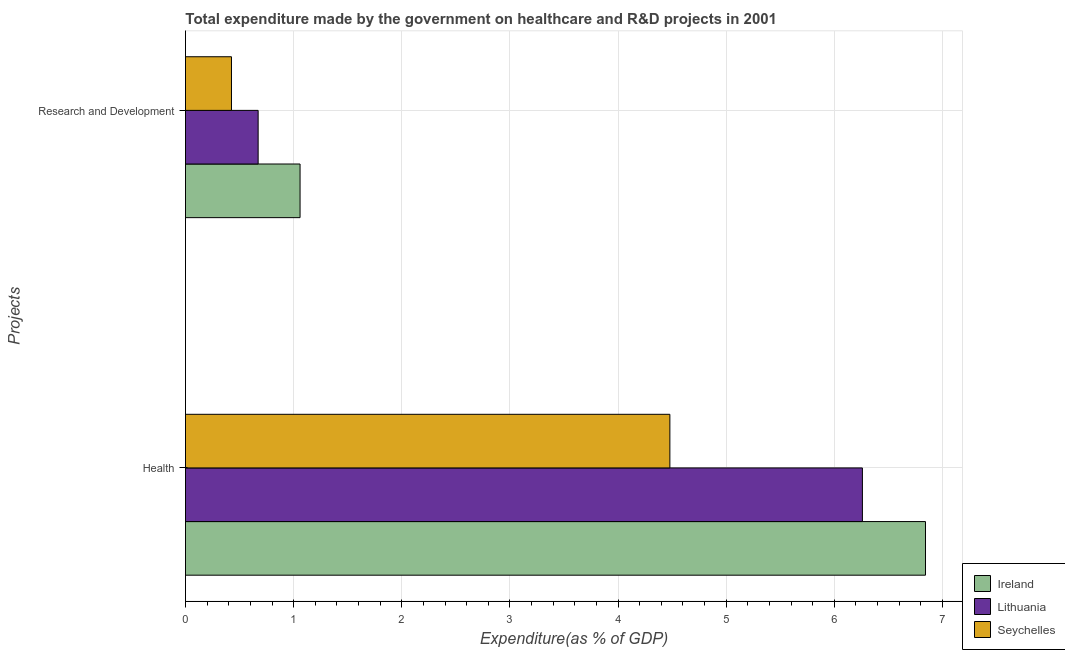How many groups of bars are there?
Your response must be concise. 2. What is the label of the 1st group of bars from the top?
Your answer should be compact. Research and Development. What is the expenditure in healthcare in Seychelles?
Offer a terse response. 4.48. Across all countries, what is the maximum expenditure in r&d?
Provide a short and direct response. 1.06. Across all countries, what is the minimum expenditure in healthcare?
Your answer should be compact. 4.48. In which country was the expenditure in r&d maximum?
Your answer should be compact. Ireland. In which country was the expenditure in r&d minimum?
Offer a terse response. Seychelles. What is the total expenditure in healthcare in the graph?
Give a very brief answer. 17.58. What is the difference between the expenditure in healthcare in Lithuania and that in Seychelles?
Make the answer very short. 1.78. What is the difference between the expenditure in r&d in Ireland and the expenditure in healthcare in Lithuania?
Keep it short and to the point. -5.2. What is the average expenditure in healthcare per country?
Your response must be concise. 5.86. What is the difference between the expenditure in healthcare and expenditure in r&d in Seychelles?
Your answer should be compact. 4.05. What is the ratio of the expenditure in healthcare in Seychelles to that in Ireland?
Your answer should be very brief. 0.65. Is the expenditure in r&d in Lithuania less than that in Seychelles?
Provide a short and direct response. No. What does the 2nd bar from the top in Research and Development represents?
Your answer should be very brief. Lithuania. What does the 1st bar from the bottom in Health represents?
Offer a very short reply. Ireland. How many bars are there?
Provide a succinct answer. 6. How many countries are there in the graph?
Your answer should be compact. 3. What is the difference between two consecutive major ticks on the X-axis?
Offer a very short reply. 1. Does the graph contain grids?
Provide a succinct answer. Yes. Where does the legend appear in the graph?
Give a very brief answer. Bottom right. How many legend labels are there?
Make the answer very short. 3. What is the title of the graph?
Give a very brief answer. Total expenditure made by the government on healthcare and R&D projects in 2001. Does "Timor-Leste" appear as one of the legend labels in the graph?
Keep it short and to the point. No. What is the label or title of the X-axis?
Offer a very short reply. Expenditure(as % of GDP). What is the label or title of the Y-axis?
Ensure brevity in your answer.  Projects. What is the Expenditure(as % of GDP) in Ireland in Health?
Ensure brevity in your answer.  6.84. What is the Expenditure(as % of GDP) of Lithuania in Health?
Give a very brief answer. 6.26. What is the Expenditure(as % of GDP) of Seychelles in Health?
Your response must be concise. 4.48. What is the Expenditure(as % of GDP) of Ireland in Research and Development?
Keep it short and to the point. 1.06. What is the Expenditure(as % of GDP) in Lithuania in Research and Development?
Ensure brevity in your answer.  0.67. What is the Expenditure(as % of GDP) of Seychelles in Research and Development?
Provide a short and direct response. 0.43. Across all Projects, what is the maximum Expenditure(as % of GDP) in Ireland?
Your answer should be very brief. 6.84. Across all Projects, what is the maximum Expenditure(as % of GDP) in Lithuania?
Keep it short and to the point. 6.26. Across all Projects, what is the maximum Expenditure(as % of GDP) of Seychelles?
Provide a succinct answer. 4.48. Across all Projects, what is the minimum Expenditure(as % of GDP) of Ireland?
Your answer should be very brief. 1.06. Across all Projects, what is the minimum Expenditure(as % of GDP) in Lithuania?
Provide a succinct answer. 0.67. Across all Projects, what is the minimum Expenditure(as % of GDP) in Seychelles?
Keep it short and to the point. 0.43. What is the total Expenditure(as % of GDP) in Ireland in the graph?
Your answer should be compact. 7.9. What is the total Expenditure(as % of GDP) of Lithuania in the graph?
Offer a very short reply. 6.93. What is the total Expenditure(as % of GDP) of Seychelles in the graph?
Offer a terse response. 4.9. What is the difference between the Expenditure(as % of GDP) in Ireland in Health and that in Research and Development?
Offer a terse response. 5.78. What is the difference between the Expenditure(as % of GDP) in Lithuania in Health and that in Research and Development?
Keep it short and to the point. 5.59. What is the difference between the Expenditure(as % of GDP) in Seychelles in Health and that in Research and Development?
Provide a succinct answer. 4.05. What is the difference between the Expenditure(as % of GDP) in Ireland in Health and the Expenditure(as % of GDP) in Lithuania in Research and Development?
Your answer should be compact. 6.17. What is the difference between the Expenditure(as % of GDP) in Ireland in Health and the Expenditure(as % of GDP) in Seychelles in Research and Development?
Offer a very short reply. 6.42. What is the difference between the Expenditure(as % of GDP) of Lithuania in Health and the Expenditure(as % of GDP) of Seychelles in Research and Development?
Keep it short and to the point. 5.83. What is the average Expenditure(as % of GDP) of Ireland per Projects?
Give a very brief answer. 3.95. What is the average Expenditure(as % of GDP) in Lithuania per Projects?
Your answer should be very brief. 3.47. What is the average Expenditure(as % of GDP) of Seychelles per Projects?
Your answer should be compact. 2.45. What is the difference between the Expenditure(as % of GDP) of Ireland and Expenditure(as % of GDP) of Lithuania in Health?
Your answer should be very brief. 0.58. What is the difference between the Expenditure(as % of GDP) of Ireland and Expenditure(as % of GDP) of Seychelles in Health?
Provide a succinct answer. 2.36. What is the difference between the Expenditure(as % of GDP) of Lithuania and Expenditure(as % of GDP) of Seychelles in Health?
Provide a succinct answer. 1.78. What is the difference between the Expenditure(as % of GDP) of Ireland and Expenditure(as % of GDP) of Lithuania in Research and Development?
Your answer should be very brief. 0.39. What is the difference between the Expenditure(as % of GDP) of Ireland and Expenditure(as % of GDP) of Seychelles in Research and Development?
Ensure brevity in your answer.  0.63. What is the difference between the Expenditure(as % of GDP) of Lithuania and Expenditure(as % of GDP) of Seychelles in Research and Development?
Provide a succinct answer. 0.25. What is the ratio of the Expenditure(as % of GDP) in Ireland in Health to that in Research and Development?
Your answer should be compact. 6.46. What is the ratio of the Expenditure(as % of GDP) in Lithuania in Health to that in Research and Development?
Ensure brevity in your answer.  9.32. What is the ratio of the Expenditure(as % of GDP) in Seychelles in Health to that in Research and Development?
Offer a terse response. 10.53. What is the difference between the highest and the second highest Expenditure(as % of GDP) of Ireland?
Offer a very short reply. 5.78. What is the difference between the highest and the second highest Expenditure(as % of GDP) in Lithuania?
Give a very brief answer. 5.59. What is the difference between the highest and the second highest Expenditure(as % of GDP) in Seychelles?
Your answer should be compact. 4.05. What is the difference between the highest and the lowest Expenditure(as % of GDP) in Ireland?
Your response must be concise. 5.78. What is the difference between the highest and the lowest Expenditure(as % of GDP) in Lithuania?
Your response must be concise. 5.59. What is the difference between the highest and the lowest Expenditure(as % of GDP) in Seychelles?
Give a very brief answer. 4.05. 